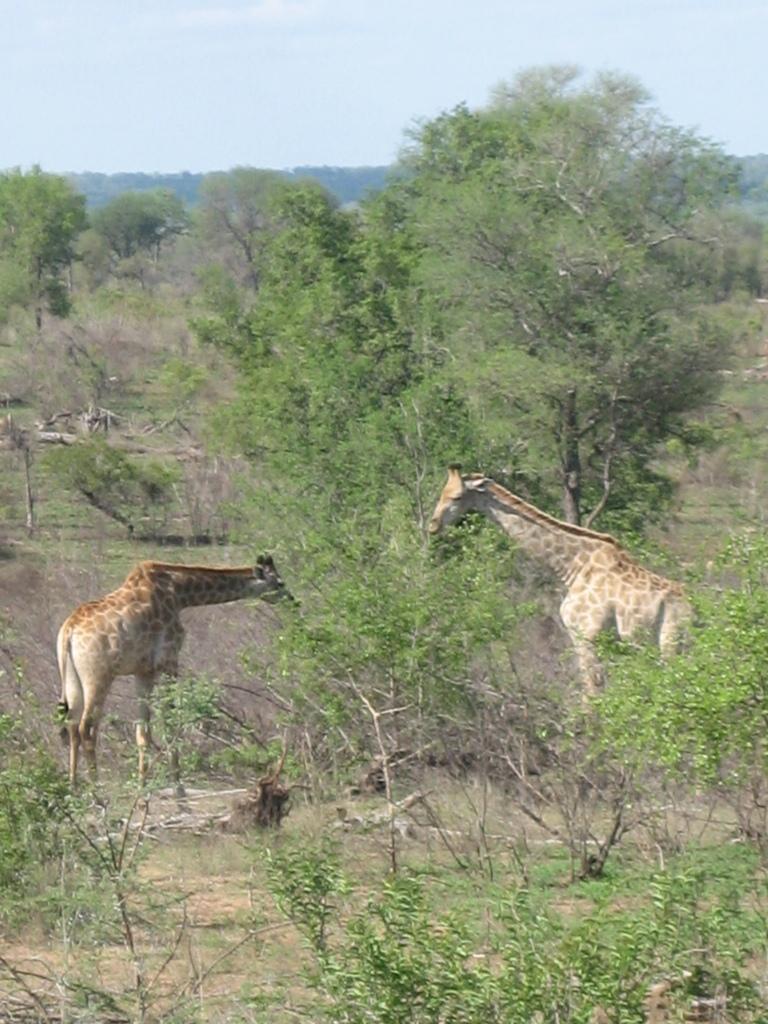Could you give a brief overview of what you see in this image? In this image we can see giraffes. Also there are trees. In the background there is sky. 